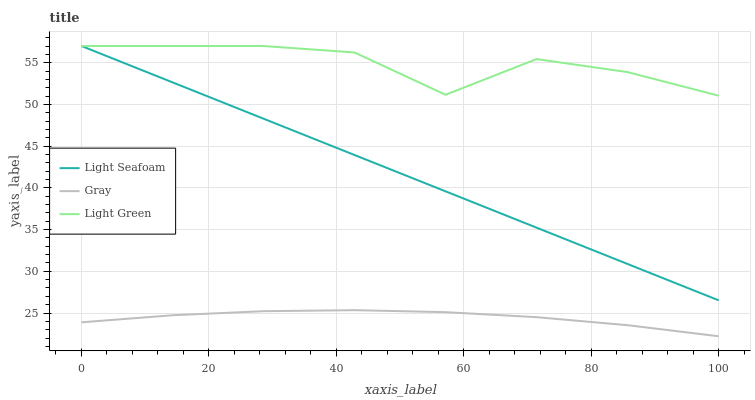Does Gray have the minimum area under the curve?
Answer yes or no. Yes. Does Light Green have the maximum area under the curve?
Answer yes or no. Yes. Does Light Seafoam have the minimum area under the curve?
Answer yes or no. No. Does Light Seafoam have the maximum area under the curve?
Answer yes or no. No. Is Light Seafoam the smoothest?
Answer yes or no. Yes. Is Light Green the roughest?
Answer yes or no. Yes. Is Light Green the smoothest?
Answer yes or no. No. Is Light Seafoam the roughest?
Answer yes or no. No. Does Gray have the lowest value?
Answer yes or no. Yes. Does Light Seafoam have the lowest value?
Answer yes or no. No. Does Light Green have the highest value?
Answer yes or no. Yes. Is Gray less than Light Green?
Answer yes or no. Yes. Is Light Green greater than Gray?
Answer yes or no. Yes. Does Light Green intersect Light Seafoam?
Answer yes or no. Yes. Is Light Green less than Light Seafoam?
Answer yes or no. No. Is Light Green greater than Light Seafoam?
Answer yes or no. No. Does Gray intersect Light Green?
Answer yes or no. No. 